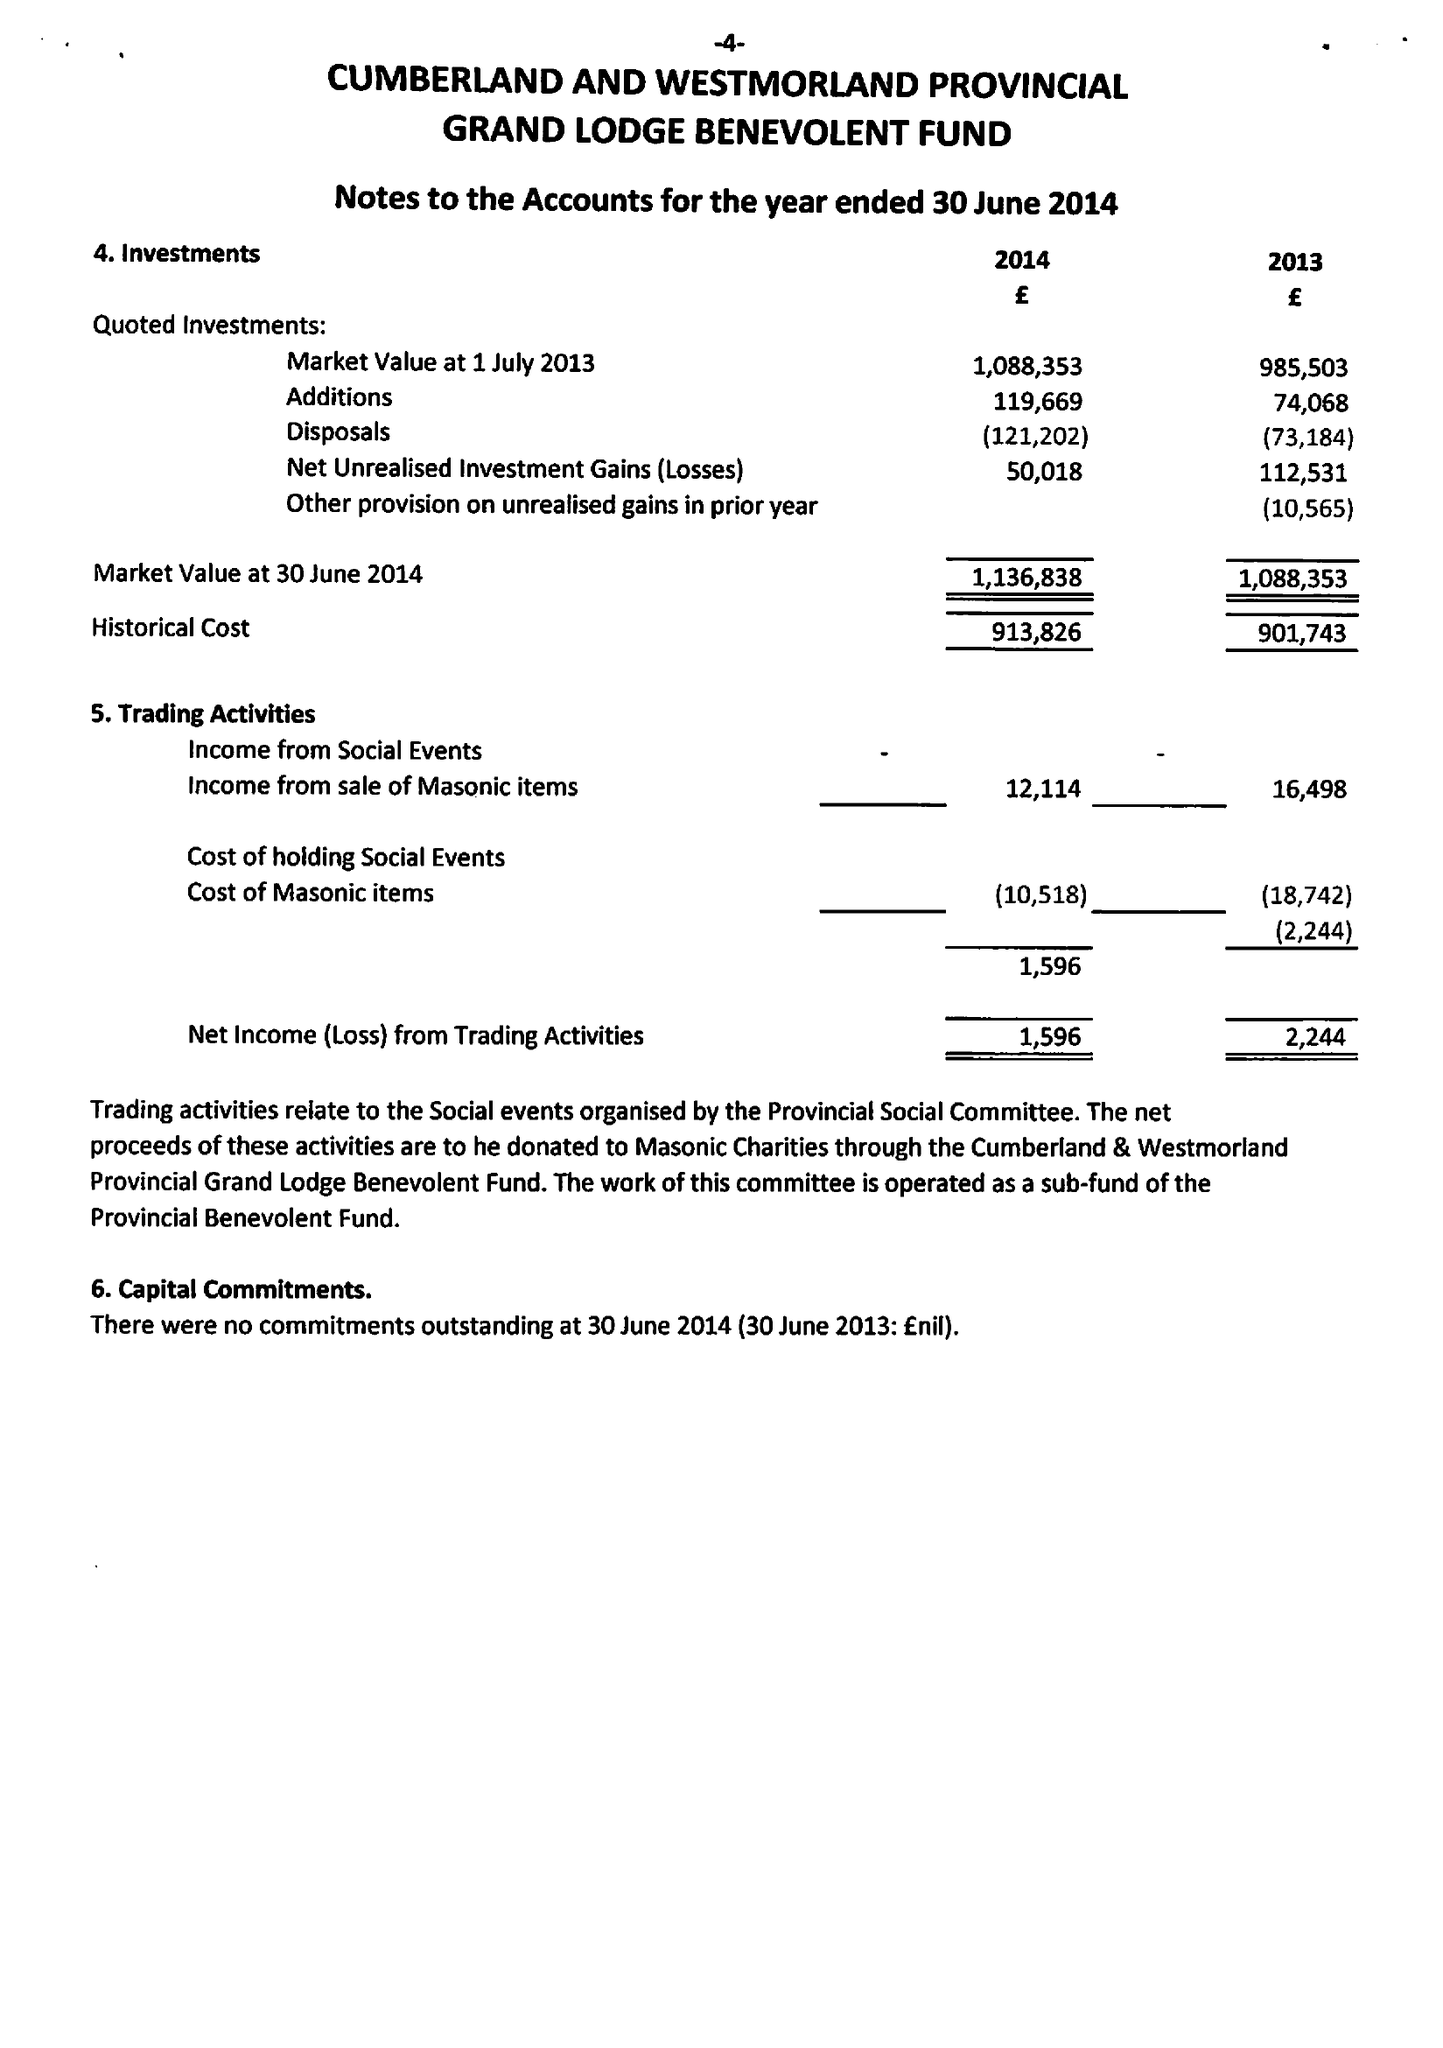What is the value for the report_date?
Answer the question using a single word or phrase. 2014-06-30 